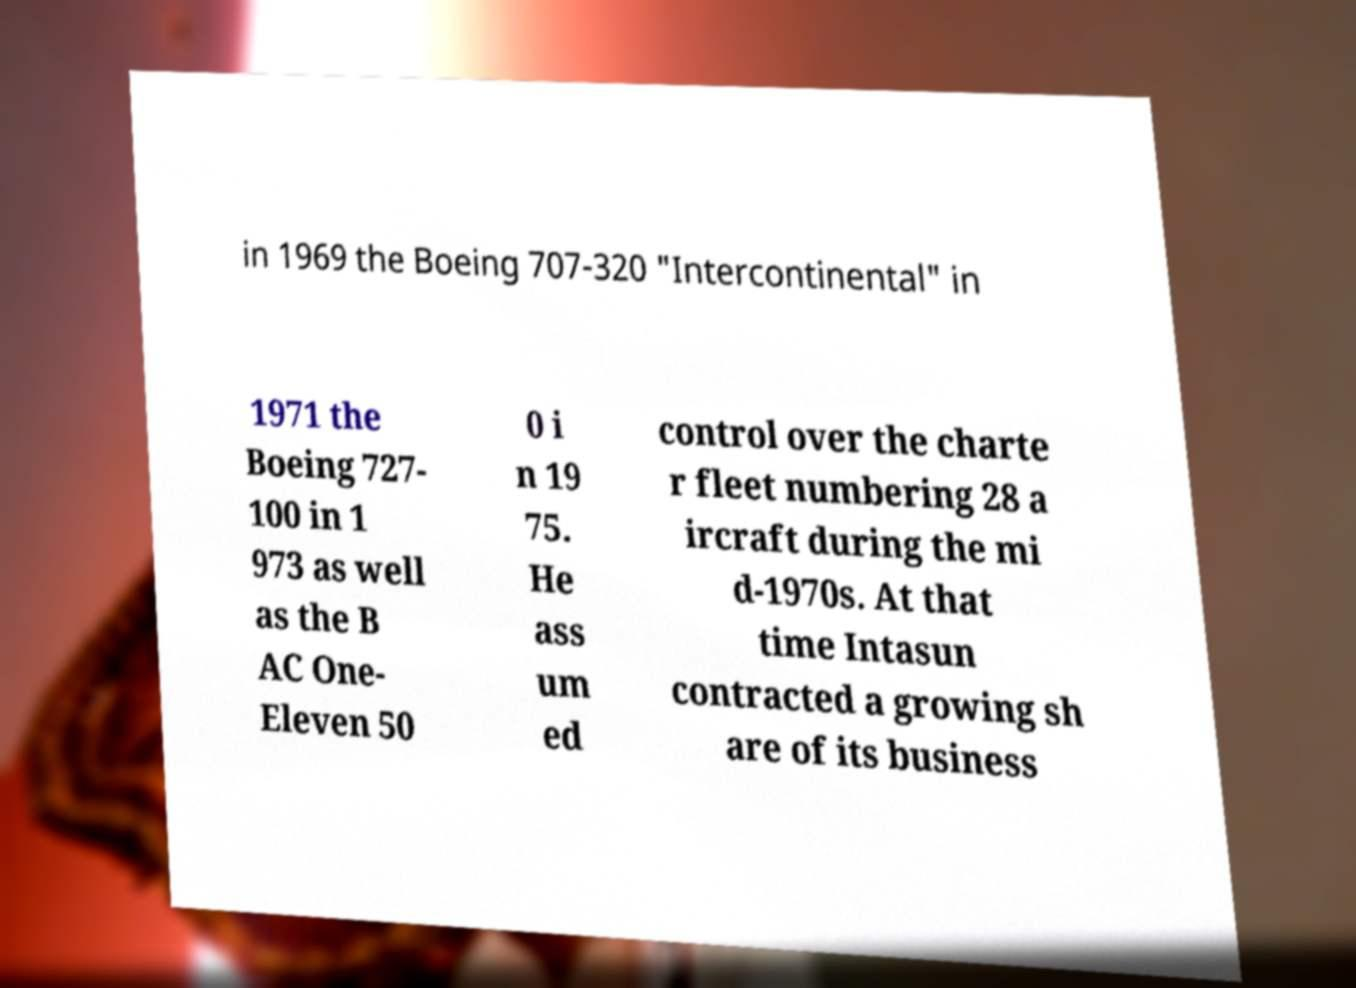What messages or text are displayed in this image? I need them in a readable, typed format. in 1969 the Boeing 707-320 "Intercontinental" in 1971 the Boeing 727- 100 in 1 973 as well as the B AC One- Eleven 50 0 i n 19 75. He ass um ed control over the charte r fleet numbering 28 a ircraft during the mi d-1970s. At that time Intasun contracted a growing sh are of its business 